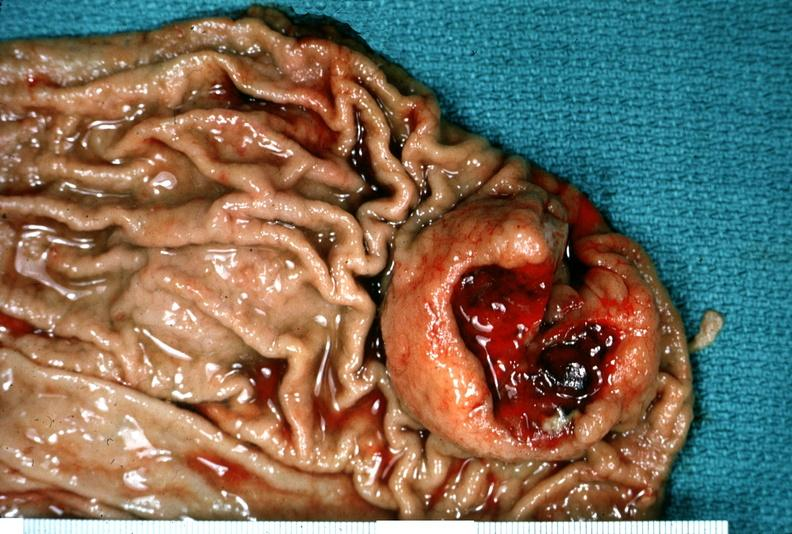s gastrointestinal present?
Answer the question using a single word or phrase. Yes 